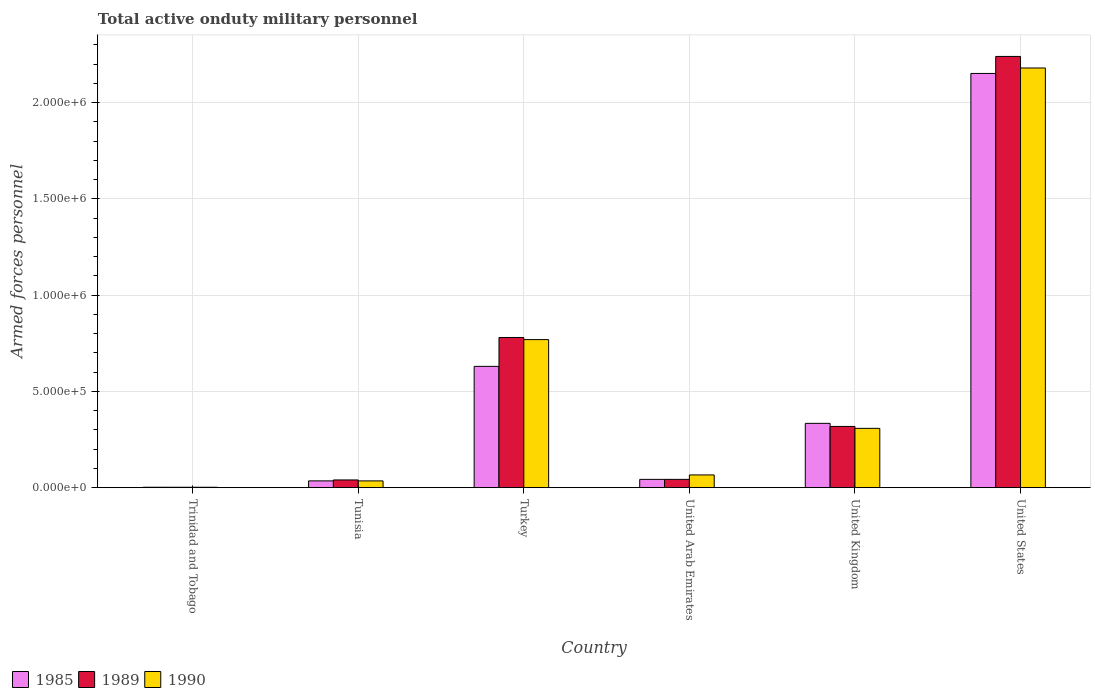How many different coloured bars are there?
Your answer should be very brief. 3. Are the number of bars per tick equal to the number of legend labels?
Provide a succinct answer. Yes. Are the number of bars on each tick of the X-axis equal?
Offer a terse response. Yes. How many bars are there on the 4th tick from the left?
Provide a short and direct response. 3. What is the label of the 3rd group of bars from the left?
Keep it short and to the point. Turkey. In how many cases, is the number of bars for a given country not equal to the number of legend labels?
Give a very brief answer. 0. What is the number of armed forces personnel in 1989 in United Kingdom?
Your response must be concise. 3.18e+05. Across all countries, what is the maximum number of armed forces personnel in 1985?
Your response must be concise. 2.15e+06. Across all countries, what is the minimum number of armed forces personnel in 1990?
Provide a succinct answer. 2000. In which country was the number of armed forces personnel in 1989 maximum?
Provide a short and direct response. United States. In which country was the number of armed forces personnel in 1990 minimum?
Keep it short and to the point. Trinidad and Tobago. What is the total number of armed forces personnel in 1990 in the graph?
Ensure brevity in your answer.  3.36e+06. What is the difference between the number of armed forces personnel in 1989 in Turkey and that in United States?
Your answer should be compact. -1.46e+06. What is the difference between the number of armed forces personnel in 1985 in United Kingdom and the number of armed forces personnel in 1990 in Tunisia?
Your answer should be very brief. 2.99e+05. What is the average number of armed forces personnel in 1990 per country?
Offer a very short reply. 5.60e+05. What is the difference between the number of armed forces personnel of/in 1990 and number of armed forces personnel of/in 1985 in United Arab Emirates?
Ensure brevity in your answer.  2.30e+04. What is the ratio of the number of armed forces personnel in 1990 in Tunisia to that in Turkey?
Provide a succinct answer. 0.05. Is the number of armed forces personnel in 1990 in United Arab Emirates less than that in United Kingdom?
Offer a very short reply. Yes. What is the difference between the highest and the second highest number of armed forces personnel in 1990?
Ensure brevity in your answer.  1.87e+06. What is the difference between the highest and the lowest number of armed forces personnel in 1990?
Keep it short and to the point. 2.18e+06. Is the sum of the number of armed forces personnel in 1989 in Turkey and United Arab Emirates greater than the maximum number of armed forces personnel in 1990 across all countries?
Make the answer very short. No. What does the 3rd bar from the left in United Arab Emirates represents?
Offer a terse response. 1990. What does the 1st bar from the right in Trinidad and Tobago represents?
Offer a terse response. 1990. How many bars are there?
Ensure brevity in your answer.  18. Are all the bars in the graph horizontal?
Your response must be concise. No. What is the difference between two consecutive major ticks on the Y-axis?
Your answer should be very brief. 5.00e+05. Are the values on the major ticks of Y-axis written in scientific E-notation?
Your response must be concise. Yes. Does the graph contain any zero values?
Give a very brief answer. No. Does the graph contain grids?
Keep it short and to the point. Yes. How are the legend labels stacked?
Provide a short and direct response. Horizontal. What is the title of the graph?
Your answer should be very brief. Total active onduty military personnel. Does "2005" appear as one of the legend labels in the graph?
Make the answer very short. No. What is the label or title of the Y-axis?
Ensure brevity in your answer.  Armed forces personnel. What is the Armed forces personnel in 1985 in Trinidad and Tobago?
Offer a terse response. 2100. What is the Armed forces personnel in 1985 in Tunisia?
Provide a succinct answer. 3.51e+04. What is the Armed forces personnel of 1989 in Tunisia?
Give a very brief answer. 4.00e+04. What is the Armed forces personnel in 1990 in Tunisia?
Give a very brief answer. 3.50e+04. What is the Armed forces personnel of 1985 in Turkey?
Make the answer very short. 6.30e+05. What is the Armed forces personnel in 1989 in Turkey?
Keep it short and to the point. 7.80e+05. What is the Armed forces personnel in 1990 in Turkey?
Provide a succinct answer. 7.69e+05. What is the Armed forces personnel in 1985 in United Arab Emirates?
Provide a succinct answer. 4.30e+04. What is the Armed forces personnel of 1989 in United Arab Emirates?
Your answer should be very brief. 4.30e+04. What is the Armed forces personnel in 1990 in United Arab Emirates?
Provide a short and direct response. 6.60e+04. What is the Armed forces personnel of 1985 in United Kingdom?
Make the answer very short. 3.34e+05. What is the Armed forces personnel of 1989 in United Kingdom?
Offer a terse response. 3.18e+05. What is the Armed forces personnel in 1990 in United Kingdom?
Your answer should be compact. 3.08e+05. What is the Armed forces personnel in 1985 in United States?
Offer a very short reply. 2.15e+06. What is the Armed forces personnel in 1989 in United States?
Offer a very short reply. 2.24e+06. What is the Armed forces personnel in 1990 in United States?
Your answer should be very brief. 2.18e+06. Across all countries, what is the maximum Armed forces personnel in 1985?
Offer a very short reply. 2.15e+06. Across all countries, what is the maximum Armed forces personnel of 1989?
Offer a very short reply. 2.24e+06. Across all countries, what is the maximum Armed forces personnel of 1990?
Your response must be concise. 2.18e+06. Across all countries, what is the minimum Armed forces personnel of 1985?
Provide a succinct answer. 2100. Across all countries, what is the minimum Armed forces personnel of 1989?
Your response must be concise. 2000. What is the total Armed forces personnel of 1985 in the graph?
Offer a very short reply. 3.20e+06. What is the total Armed forces personnel in 1989 in the graph?
Provide a succinct answer. 3.42e+06. What is the total Armed forces personnel in 1990 in the graph?
Make the answer very short. 3.36e+06. What is the difference between the Armed forces personnel of 1985 in Trinidad and Tobago and that in Tunisia?
Offer a terse response. -3.30e+04. What is the difference between the Armed forces personnel in 1989 in Trinidad and Tobago and that in Tunisia?
Ensure brevity in your answer.  -3.80e+04. What is the difference between the Armed forces personnel of 1990 in Trinidad and Tobago and that in Tunisia?
Offer a very short reply. -3.30e+04. What is the difference between the Armed forces personnel in 1985 in Trinidad and Tobago and that in Turkey?
Your response must be concise. -6.28e+05. What is the difference between the Armed forces personnel of 1989 in Trinidad and Tobago and that in Turkey?
Offer a very short reply. -7.78e+05. What is the difference between the Armed forces personnel in 1990 in Trinidad and Tobago and that in Turkey?
Your response must be concise. -7.67e+05. What is the difference between the Armed forces personnel of 1985 in Trinidad and Tobago and that in United Arab Emirates?
Offer a terse response. -4.09e+04. What is the difference between the Armed forces personnel of 1989 in Trinidad and Tobago and that in United Arab Emirates?
Your response must be concise. -4.10e+04. What is the difference between the Armed forces personnel of 1990 in Trinidad and Tobago and that in United Arab Emirates?
Your answer should be very brief. -6.40e+04. What is the difference between the Armed forces personnel of 1985 in Trinidad and Tobago and that in United Kingdom?
Provide a short and direct response. -3.32e+05. What is the difference between the Armed forces personnel of 1989 in Trinidad and Tobago and that in United Kingdom?
Offer a very short reply. -3.16e+05. What is the difference between the Armed forces personnel in 1990 in Trinidad and Tobago and that in United Kingdom?
Keep it short and to the point. -3.06e+05. What is the difference between the Armed forces personnel of 1985 in Trinidad and Tobago and that in United States?
Ensure brevity in your answer.  -2.15e+06. What is the difference between the Armed forces personnel in 1989 in Trinidad and Tobago and that in United States?
Offer a terse response. -2.24e+06. What is the difference between the Armed forces personnel of 1990 in Trinidad and Tobago and that in United States?
Provide a succinct answer. -2.18e+06. What is the difference between the Armed forces personnel in 1985 in Tunisia and that in Turkey?
Ensure brevity in your answer.  -5.95e+05. What is the difference between the Armed forces personnel in 1989 in Tunisia and that in Turkey?
Give a very brief answer. -7.40e+05. What is the difference between the Armed forces personnel of 1990 in Tunisia and that in Turkey?
Ensure brevity in your answer.  -7.34e+05. What is the difference between the Armed forces personnel of 1985 in Tunisia and that in United Arab Emirates?
Your response must be concise. -7900. What is the difference between the Armed forces personnel in 1989 in Tunisia and that in United Arab Emirates?
Ensure brevity in your answer.  -3000. What is the difference between the Armed forces personnel of 1990 in Tunisia and that in United Arab Emirates?
Provide a short and direct response. -3.10e+04. What is the difference between the Armed forces personnel of 1985 in Tunisia and that in United Kingdom?
Your answer should be compact. -2.99e+05. What is the difference between the Armed forces personnel in 1989 in Tunisia and that in United Kingdom?
Offer a very short reply. -2.78e+05. What is the difference between the Armed forces personnel in 1990 in Tunisia and that in United Kingdom?
Keep it short and to the point. -2.73e+05. What is the difference between the Armed forces personnel of 1985 in Tunisia and that in United States?
Provide a short and direct response. -2.12e+06. What is the difference between the Armed forces personnel in 1989 in Tunisia and that in United States?
Offer a very short reply. -2.20e+06. What is the difference between the Armed forces personnel in 1990 in Tunisia and that in United States?
Offer a very short reply. -2.14e+06. What is the difference between the Armed forces personnel in 1985 in Turkey and that in United Arab Emirates?
Provide a short and direct response. 5.87e+05. What is the difference between the Armed forces personnel in 1989 in Turkey and that in United Arab Emirates?
Keep it short and to the point. 7.37e+05. What is the difference between the Armed forces personnel of 1990 in Turkey and that in United Arab Emirates?
Provide a succinct answer. 7.03e+05. What is the difference between the Armed forces personnel of 1985 in Turkey and that in United Kingdom?
Keep it short and to the point. 2.96e+05. What is the difference between the Armed forces personnel of 1989 in Turkey and that in United Kingdom?
Offer a very short reply. 4.62e+05. What is the difference between the Armed forces personnel in 1990 in Turkey and that in United Kingdom?
Keep it short and to the point. 4.61e+05. What is the difference between the Armed forces personnel of 1985 in Turkey and that in United States?
Provide a short and direct response. -1.52e+06. What is the difference between the Armed forces personnel of 1989 in Turkey and that in United States?
Your answer should be very brief. -1.46e+06. What is the difference between the Armed forces personnel of 1990 in Turkey and that in United States?
Provide a succinct answer. -1.41e+06. What is the difference between the Armed forces personnel of 1985 in United Arab Emirates and that in United Kingdom?
Provide a short and direct response. -2.91e+05. What is the difference between the Armed forces personnel in 1989 in United Arab Emirates and that in United Kingdom?
Your response must be concise. -2.75e+05. What is the difference between the Armed forces personnel of 1990 in United Arab Emirates and that in United Kingdom?
Your response must be concise. -2.42e+05. What is the difference between the Armed forces personnel of 1985 in United Arab Emirates and that in United States?
Provide a short and direct response. -2.11e+06. What is the difference between the Armed forces personnel of 1989 in United Arab Emirates and that in United States?
Provide a succinct answer. -2.20e+06. What is the difference between the Armed forces personnel in 1990 in United Arab Emirates and that in United States?
Make the answer very short. -2.11e+06. What is the difference between the Armed forces personnel of 1985 in United Kingdom and that in United States?
Your answer should be compact. -1.82e+06. What is the difference between the Armed forces personnel of 1989 in United Kingdom and that in United States?
Your answer should be very brief. -1.92e+06. What is the difference between the Armed forces personnel of 1990 in United Kingdom and that in United States?
Ensure brevity in your answer.  -1.87e+06. What is the difference between the Armed forces personnel in 1985 in Trinidad and Tobago and the Armed forces personnel in 1989 in Tunisia?
Make the answer very short. -3.79e+04. What is the difference between the Armed forces personnel of 1985 in Trinidad and Tobago and the Armed forces personnel of 1990 in Tunisia?
Your answer should be very brief. -3.29e+04. What is the difference between the Armed forces personnel of 1989 in Trinidad and Tobago and the Armed forces personnel of 1990 in Tunisia?
Make the answer very short. -3.30e+04. What is the difference between the Armed forces personnel in 1985 in Trinidad and Tobago and the Armed forces personnel in 1989 in Turkey?
Offer a terse response. -7.78e+05. What is the difference between the Armed forces personnel in 1985 in Trinidad and Tobago and the Armed forces personnel in 1990 in Turkey?
Provide a short and direct response. -7.67e+05. What is the difference between the Armed forces personnel in 1989 in Trinidad and Tobago and the Armed forces personnel in 1990 in Turkey?
Your response must be concise. -7.67e+05. What is the difference between the Armed forces personnel of 1985 in Trinidad and Tobago and the Armed forces personnel of 1989 in United Arab Emirates?
Keep it short and to the point. -4.09e+04. What is the difference between the Armed forces personnel in 1985 in Trinidad and Tobago and the Armed forces personnel in 1990 in United Arab Emirates?
Provide a short and direct response. -6.39e+04. What is the difference between the Armed forces personnel in 1989 in Trinidad and Tobago and the Armed forces personnel in 1990 in United Arab Emirates?
Ensure brevity in your answer.  -6.40e+04. What is the difference between the Armed forces personnel in 1985 in Trinidad and Tobago and the Armed forces personnel in 1989 in United Kingdom?
Make the answer very short. -3.16e+05. What is the difference between the Armed forces personnel in 1985 in Trinidad and Tobago and the Armed forces personnel in 1990 in United Kingdom?
Keep it short and to the point. -3.06e+05. What is the difference between the Armed forces personnel of 1989 in Trinidad and Tobago and the Armed forces personnel of 1990 in United Kingdom?
Offer a very short reply. -3.06e+05. What is the difference between the Armed forces personnel in 1985 in Trinidad and Tobago and the Armed forces personnel in 1989 in United States?
Offer a very short reply. -2.24e+06. What is the difference between the Armed forces personnel in 1985 in Trinidad and Tobago and the Armed forces personnel in 1990 in United States?
Ensure brevity in your answer.  -2.18e+06. What is the difference between the Armed forces personnel in 1989 in Trinidad and Tobago and the Armed forces personnel in 1990 in United States?
Your answer should be very brief. -2.18e+06. What is the difference between the Armed forces personnel in 1985 in Tunisia and the Armed forces personnel in 1989 in Turkey?
Keep it short and to the point. -7.45e+05. What is the difference between the Armed forces personnel of 1985 in Tunisia and the Armed forces personnel of 1990 in Turkey?
Offer a very short reply. -7.34e+05. What is the difference between the Armed forces personnel of 1989 in Tunisia and the Armed forces personnel of 1990 in Turkey?
Your answer should be compact. -7.29e+05. What is the difference between the Armed forces personnel of 1985 in Tunisia and the Armed forces personnel of 1989 in United Arab Emirates?
Ensure brevity in your answer.  -7900. What is the difference between the Armed forces personnel of 1985 in Tunisia and the Armed forces personnel of 1990 in United Arab Emirates?
Your answer should be compact. -3.09e+04. What is the difference between the Armed forces personnel in 1989 in Tunisia and the Armed forces personnel in 1990 in United Arab Emirates?
Offer a very short reply. -2.60e+04. What is the difference between the Armed forces personnel of 1985 in Tunisia and the Armed forces personnel of 1989 in United Kingdom?
Keep it short and to the point. -2.83e+05. What is the difference between the Armed forces personnel in 1985 in Tunisia and the Armed forces personnel in 1990 in United Kingdom?
Ensure brevity in your answer.  -2.73e+05. What is the difference between the Armed forces personnel of 1989 in Tunisia and the Armed forces personnel of 1990 in United Kingdom?
Offer a very short reply. -2.68e+05. What is the difference between the Armed forces personnel in 1985 in Tunisia and the Armed forces personnel in 1989 in United States?
Your answer should be compact. -2.20e+06. What is the difference between the Armed forces personnel of 1985 in Tunisia and the Armed forces personnel of 1990 in United States?
Give a very brief answer. -2.14e+06. What is the difference between the Armed forces personnel in 1989 in Tunisia and the Armed forces personnel in 1990 in United States?
Ensure brevity in your answer.  -2.14e+06. What is the difference between the Armed forces personnel of 1985 in Turkey and the Armed forces personnel of 1989 in United Arab Emirates?
Offer a very short reply. 5.87e+05. What is the difference between the Armed forces personnel of 1985 in Turkey and the Armed forces personnel of 1990 in United Arab Emirates?
Keep it short and to the point. 5.64e+05. What is the difference between the Armed forces personnel of 1989 in Turkey and the Armed forces personnel of 1990 in United Arab Emirates?
Give a very brief answer. 7.14e+05. What is the difference between the Armed forces personnel in 1985 in Turkey and the Armed forces personnel in 1989 in United Kingdom?
Make the answer very short. 3.12e+05. What is the difference between the Armed forces personnel of 1985 in Turkey and the Armed forces personnel of 1990 in United Kingdom?
Your response must be concise. 3.22e+05. What is the difference between the Armed forces personnel in 1989 in Turkey and the Armed forces personnel in 1990 in United Kingdom?
Your answer should be compact. 4.72e+05. What is the difference between the Armed forces personnel of 1985 in Turkey and the Armed forces personnel of 1989 in United States?
Give a very brief answer. -1.61e+06. What is the difference between the Armed forces personnel in 1985 in Turkey and the Armed forces personnel in 1990 in United States?
Provide a succinct answer. -1.55e+06. What is the difference between the Armed forces personnel of 1989 in Turkey and the Armed forces personnel of 1990 in United States?
Ensure brevity in your answer.  -1.40e+06. What is the difference between the Armed forces personnel in 1985 in United Arab Emirates and the Armed forces personnel in 1989 in United Kingdom?
Provide a succinct answer. -2.75e+05. What is the difference between the Armed forces personnel in 1985 in United Arab Emirates and the Armed forces personnel in 1990 in United Kingdom?
Ensure brevity in your answer.  -2.65e+05. What is the difference between the Armed forces personnel of 1989 in United Arab Emirates and the Armed forces personnel of 1990 in United Kingdom?
Give a very brief answer. -2.65e+05. What is the difference between the Armed forces personnel in 1985 in United Arab Emirates and the Armed forces personnel in 1989 in United States?
Offer a terse response. -2.20e+06. What is the difference between the Armed forces personnel in 1985 in United Arab Emirates and the Armed forces personnel in 1990 in United States?
Keep it short and to the point. -2.14e+06. What is the difference between the Armed forces personnel in 1989 in United Arab Emirates and the Armed forces personnel in 1990 in United States?
Give a very brief answer. -2.14e+06. What is the difference between the Armed forces personnel of 1985 in United Kingdom and the Armed forces personnel of 1989 in United States?
Your response must be concise. -1.91e+06. What is the difference between the Armed forces personnel in 1985 in United Kingdom and the Armed forces personnel in 1990 in United States?
Your answer should be compact. -1.85e+06. What is the difference between the Armed forces personnel in 1989 in United Kingdom and the Armed forces personnel in 1990 in United States?
Provide a short and direct response. -1.86e+06. What is the average Armed forces personnel in 1985 per country?
Your answer should be compact. 5.33e+05. What is the average Armed forces personnel of 1989 per country?
Ensure brevity in your answer.  5.70e+05. What is the average Armed forces personnel in 1990 per country?
Keep it short and to the point. 5.60e+05. What is the difference between the Armed forces personnel in 1985 and Armed forces personnel in 1989 in Trinidad and Tobago?
Your answer should be very brief. 100. What is the difference between the Armed forces personnel of 1985 and Armed forces personnel of 1990 in Trinidad and Tobago?
Give a very brief answer. 100. What is the difference between the Armed forces personnel of 1989 and Armed forces personnel of 1990 in Trinidad and Tobago?
Keep it short and to the point. 0. What is the difference between the Armed forces personnel in 1985 and Armed forces personnel in 1989 in Tunisia?
Keep it short and to the point. -4900. What is the difference between the Armed forces personnel of 1989 and Armed forces personnel of 1990 in Tunisia?
Offer a terse response. 5000. What is the difference between the Armed forces personnel of 1985 and Armed forces personnel of 1989 in Turkey?
Your response must be concise. -1.50e+05. What is the difference between the Armed forces personnel in 1985 and Armed forces personnel in 1990 in Turkey?
Offer a very short reply. -1.39e+05. What is the difference between the Armed forces personnel of 1989 and Armed forces personnel of 1990 in Turkey?
Offer a terse response. 1.10e+04. What is the difference between the Armed forces personnel in 1985 and Armed forces personnel in 1989 in United Arab Emirates?
Your response must be concise. 0. What is the difference between the Armed forces personnel of 1985 and Armed forces personnel of 1990 in United Arab Emirates?
Ensure brevity in your answer.  -2.30e+04. What is the difference between the Armed forces personnel in 1989 and Armed forces personnel in 1990 in United Arab Emirates?
Make the answer very short. -2.30e+04. What is the difference between the Armed forces personnel of 1985 and Armed forces personnel of 1989 in United Kingdom?
Provide a short and direct response. 1.60e+04. What is the difference between the Armed forces personnel in 1985 and Armed forces personnel in 1990 in United Kingdom?
Ensure brevity in your answer.  2.60e+04. What is the difference between the Armed forces personnel of 1985 and Armed forces personnel of 1989 in United States?
Your answer should be compact. -8.84e+04. What is the difference between the Armed forces personnel in 1985 and Armed forces personnel in 1990 in United States?
Your response must be concise. -2.84e+04. What is the ratio of the Armed forces personnel of 1985 in Trinidad and Tobago to that in Tunisia?
Offer a terse response. 0.06. What is the ratio of the Armed forces personnel in 1989 in Trinidad and Tobago to that in Tunisia?
Your answer should be compact. 0.05. What is the ratio of the Armed forces personnel in 1990 in Trinidad and Tobago to that in Tunisia?
Your answer should be compact. 0.06. What is the ratio of the Armed forces personnel of 1985 in Trinidad and Tobago to that in Turkey?
Ensure brevity in your answer.  0. What is the ratio of the Armed forces personnel of 1989 in Trinidad and Tobago to that in Turkey?
Offer a very short reply. 0. What is the ratio of the Armed forces personnel in 1990 in Trinidad and Tobago to that in Turkey?
Your answer should be compact. 0. What is the ratio of the Armed forces personnel of 1985 in Trinidad and Tobago to that in United Arab Emirates?
Ensure brevity in your answer.  0.05. What is the ratio of the Armed forces personnel in 1989 in Trinidad and Tobago to that in United Arab Emirates?
Your response must be concise. 0.05. What is the ratio of the Armed forces personnel in 1990 in Trinidad and Tobago to that in United Arab Emirates?
Give a very brief answer. 0.03. What is the ratio of the Armed forces personnel in 1985 in Trinidad and Tobago to that in United Kingdom?
Make the answer very short. 0.01. What is the ratio of the Armed forces personnel in 1989 in Trinidad and Tobago to that in United Kingdom?
Ensure brevity in your answer.  0.01. What is the ratio of the Armed forces personnel in 1990 in Trinidad and Tobago to that in United Kingdom?
Your answer should be compact. 0.01. What is the ratio of the Armed forces personnel in 1985 in Trinidad and Tobago to that in United States?
Give a very brief answer. 0. What is the ratio of the Armed forces personnel in 1989 in Trinidad and Tobago to that in United States?
Offer a terse response. 0. What is the ratio of the Armed forces personnel of 1990 in Trinidad and Tobago to that in United States?
Ensure brevity in your answer.  0. What is the ratio of the Armed forces personnel of 1985 in Tunisia to that in Turkey?
Make the answer very short. 0.06. What is the ratio of the Armed forces personnel of 1989 in Tunisia to that in Turkey?
Make the answer very short. 0.05. What is the ratio of the Armed forces personnel of 1990 in Tunisia to that in Turkey?
Keep it short and to the point. 0.05. What is the ratio of the Armed forces personnel of 1985 in Tunisia to that in United Arab Emirates?
Provide a short and direct response. 0.82. What is the ratio of the Armed forces personnel in 1989 in Tunisia to that in United Arab Emirates?
Give a very brief answer. 0.93. What is the ratio of the Armed forces personnel of 1990 in Tunisia to that in United Arab Emirates?
Your response must be concise. 0.53. What is the ratio of the Armed forces personnel in 1985 in Tunisia to that in United Kingdom?
Ensure brevity in your answer.  0.11. What is the ratio of the Armed forces personnel of 1989 in Tunisia to that in United Kingdom?
Provide a short and direct response. 0.13. What is the ratio of the Armed forces personnel in 1990 in Tunisia to that in United Kingdom?
Ensure brevity in your answer.  0.11. What is the ratio of the Armed forces personnel of 1985 in Tunisia to that in United States?
Provide a short and direct response. 0.02. What is the ratio of the Armed forces personnel in 1989 in Tunisia to that in United States?
Provide a succinct answer. 0.02. What is the ratio of the Armed forces personnel in 1990 in Tunisia to that in United States?
Provide a short and direct response. 0.02. What is the ratio of the Armed forces personnel of 1985 in Turkey to that in United Arab Emirates?
Your answer should be very brief. 14.65. What is the ratio of the Armed forces personnel in 1989 in Turkey to that in United Arab Emirates?
Your answer should be compact. 18.14. What is the ratio of the Armed forces personnel of 1990 in Turkey to that in United Arab Emirates?
Your response must be concise. 11.65. What is the ratio of the Armed forces personnel of 1985 in Turkey to that in United Kingdom?
Your answer should be very brief. 1.89. What is the ratio of the Armed forces personnel in 1989 in Turkey to that in United Kingdom?
Your answer should be very brief. 2.45. What is the ratio of the Armed forces personnel of 1990 in Turkey to that in United Kingdom?
Your answer should be compact. 2.5. What is the ratio of the Armed forces personnel in 1985 in Turkey to that in United States?
Your answer should be very brief. 0.29. What is the ratio of the Armed forces personnel in 1989 in Turkey to that in United States?
Offer a very short reply. 0.35. What is the ratio of the Armed forces personnel in 1990 in Turkey to that in United States?
Your answer should be very brief. 0.35. What is the ratio of the Armed forces personnel of 1985 in United Arab Emirates to that in United Kingdom?
Make the answer very short. 0.13. What is the ratio of the Armed forces personnel of 1989 in United Arab Emirates to that in United Kingdom?
Your response must be concise. 0.14. What is the ratio of the Armed forces personnel of 1990 in United Arab Emirates to that in United Kingdom?
Ensure brevity in your answer.  0.21. What is the ratio of the Armed forces personnel in 1989 in United Arab Emirates to that in United States?
Make the answer very short. 0.02. What is the ratio of the Armed forces personnel of 1990 in United Arab Emirates to that in United States?
Your answer should be compact. 0.03. What is the ratio of the Armed forces personnel of 1985 in United Kingdom to that in United States?
Offer a terse response. 0.16. What is the ratio of the Armed forces personnel in 1989 in United Kingdom to that in United States?
Your answer should be very brief. 0.14. What is the ratio of the Armed forces personnel in 1990 in United Kingdom to that in United States?
Give a very brief answer. 0.14. What is the difference between the highest and the second highest Armed forces personnel in 1985?
Give a very brief answer. 1.52e+06. What is the difference between the highest and the second highest Armed forces personnel in 1989?
Make the answer very short. 1.46e+06. What is the difference between the highest and the second highest Armed forces personnel of 1990?
Your response must be concise. 1.41e+06. What is the difference between the highest and the lowest Armed forces personnel in 1985?
Your answer should be very brief. 2.15e+06. What is the difference between the highest and the lowest Armed forces personnel of 1989?
Ensure brevity in your answer.  2.24e+06. What is the difference between the highest and the lowest Armed forces personnel of 1990?
Provide a succinct answer. 2.18e+06. 